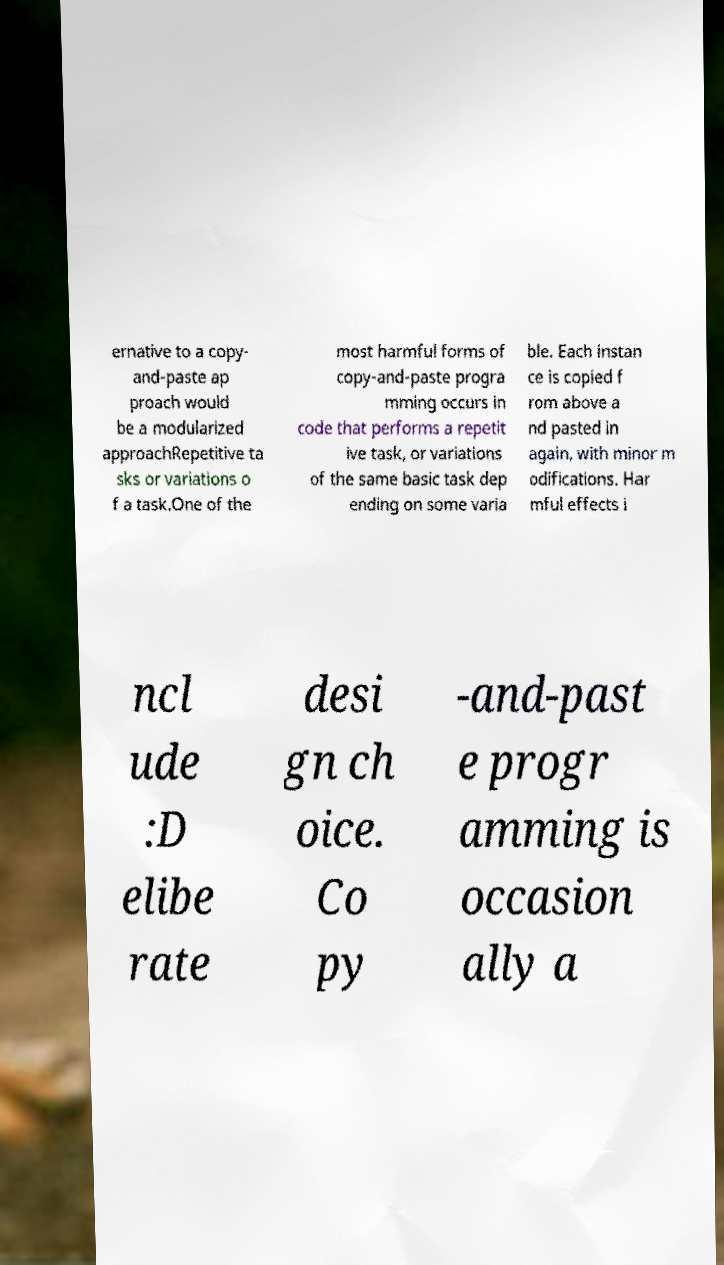Can you accurately transcribe the text from the provided image for me? ernative to a copy- and-paste ap proach would be a modularized approachRepetitive ta sks or variations o f a task.One of the most harmful forms of copy-and-paste progra mming occurs in code that performs a repetit ive task, or variations of the same basic task dep ending on some varia ble. Each instan ce is copied f rom above a nd pasted in again, with minor m odifications. Har mful effects i ncl ude :D elibe rate desi gn ch oice. Co py -and-past e progr amming is occasion ally a 